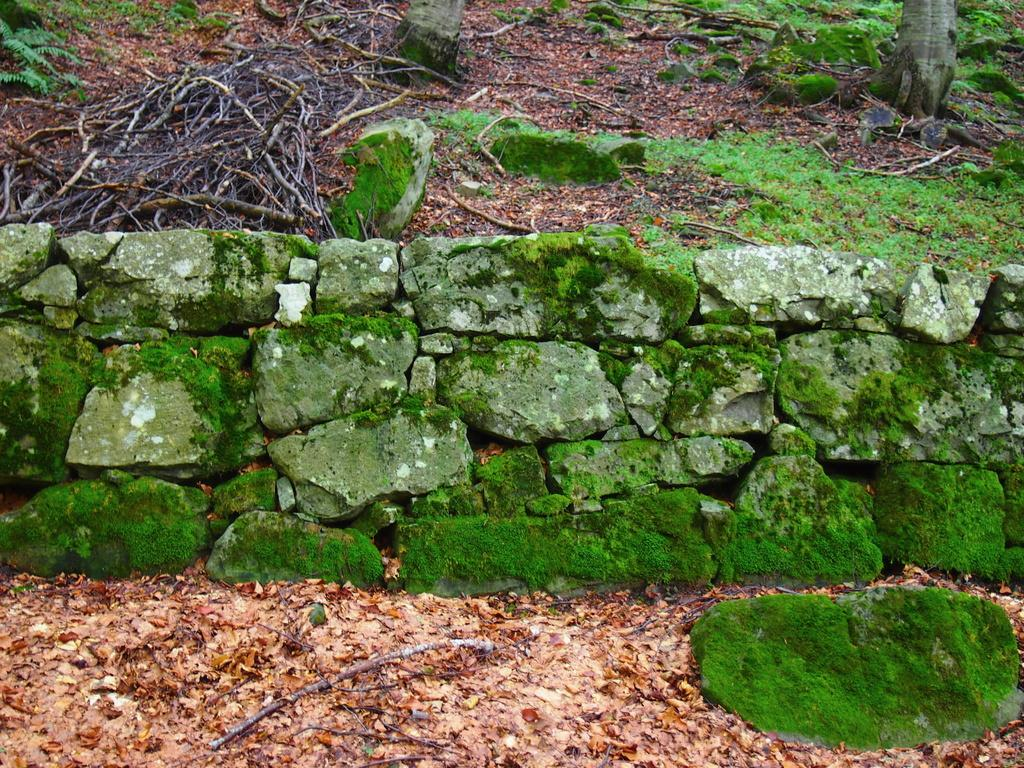What is located at the bottom of the image? There is a green stone, sticks, and dry leaves at the bottom of the image. What can be seen on the stone wall in the center of the image? Green algae is present on a stone wall in the center of the image. What is visible at the top of the image? Sticks, leaves, trees, and rocks are visible at the top of the image. Are there any grapes growing on the trees at the top of the image? There is no mention of grapes or trees with grapes in the image; it features a green stone, sticks, dry leaves, green algae, and rocks. Is there any sleet visible in the image? There is no mention of sleet in the image; it features a green stone, sticks, dry leaves, green algae, and rocks. Is there a ball visible in the image? There is no mention of a ball in the image; it features a green stone, sticks, dry leaves, green algae, and rocks. 